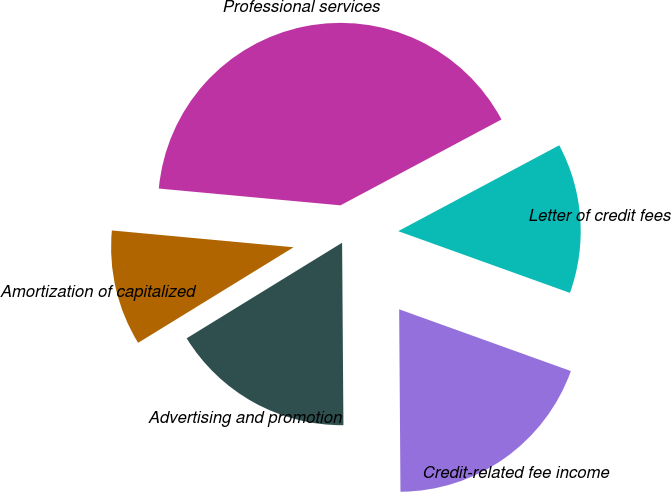Convert chart. <chart><loc_0><loc_0><loc_500><loc_500><pie_chart><fcel>Credit-related fee income<fcel>Letter of credit fees<fcel>Professional services<fcel>Amortization of capitalized<fcel>Advertising and promotion<nl><fcel>19.39%<fcel>13.29%<fcel>40.73%<fcel>10.24%<fcel>16.34%<nl></chart> 